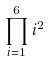Convert formula to latex. <formula><loc_0><loc_0><loc_500><loc_500>\prod _ { i = 1 } ^ { 6 } i ^ { 2 }</formula> 